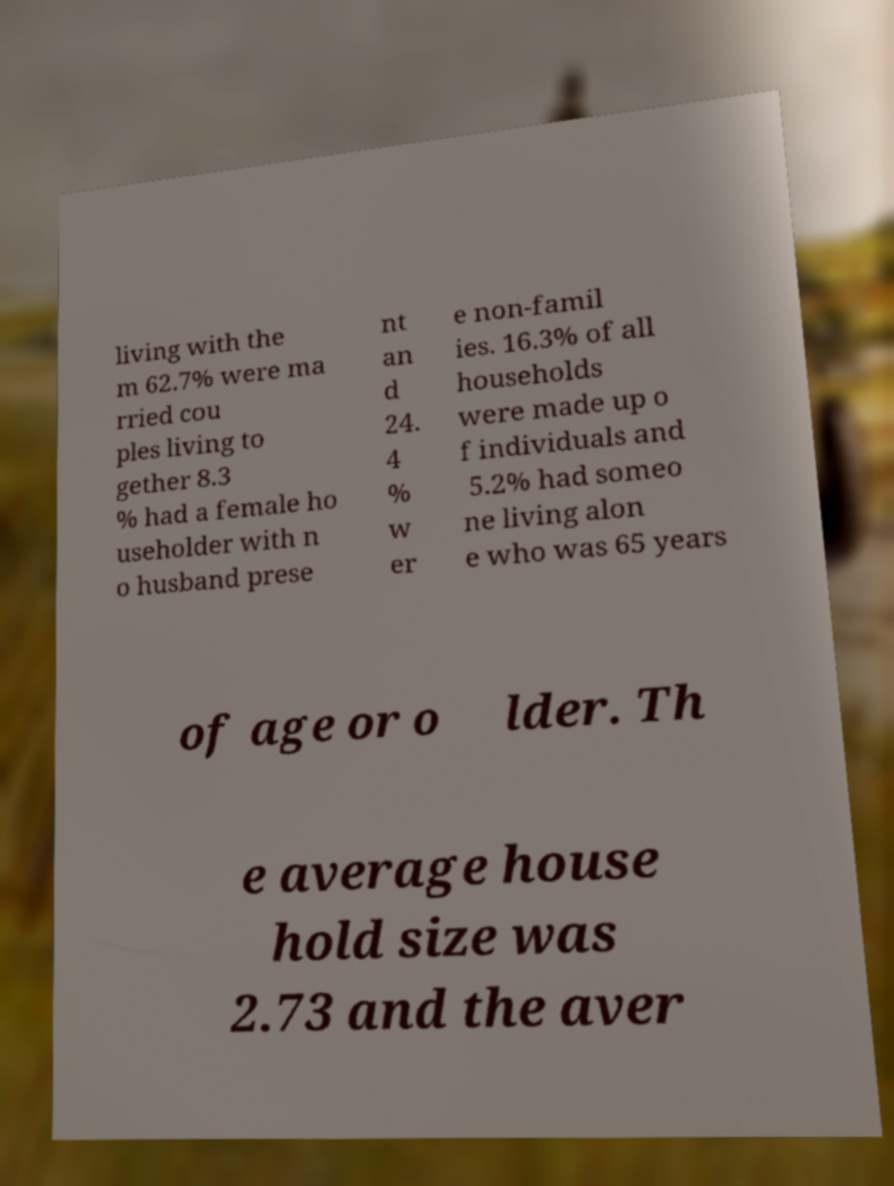There's text embedded in this image that I need extracted. Can you transcribe it verbatim? living with the m 62.7% were ma rried cou ples living to gether 8.3 % had a female ho useholder with n o husband prese nt an d 24. 4 % w er e non-famil ies. 16.3% of all households were made up o f individuals and 5.2% had someo ne living alon e who was 65 years of age or o lder. Th e average house hold size was 2.73 and the aver 